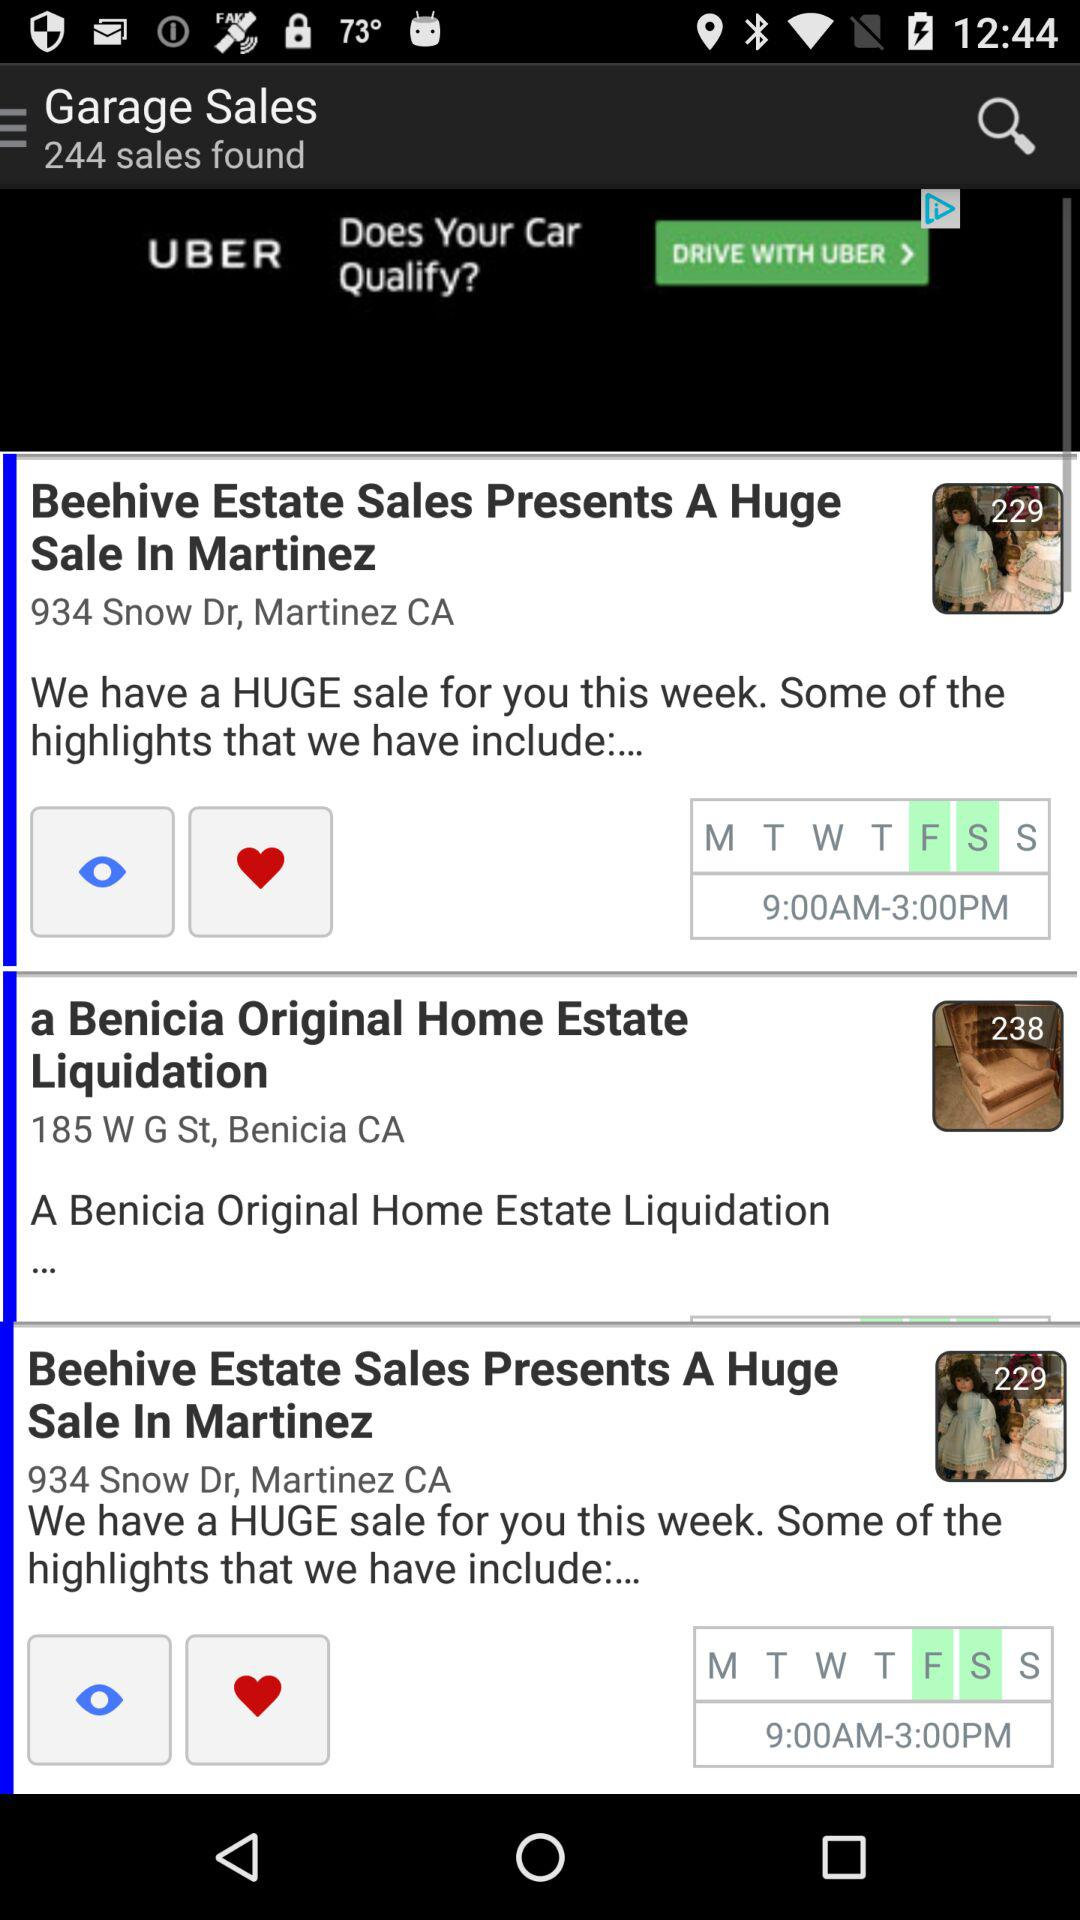What is the mentioned timing for "Beehive Estate Sales"? The mentioned timing is from 9:00 AM to 3:00 PM. 